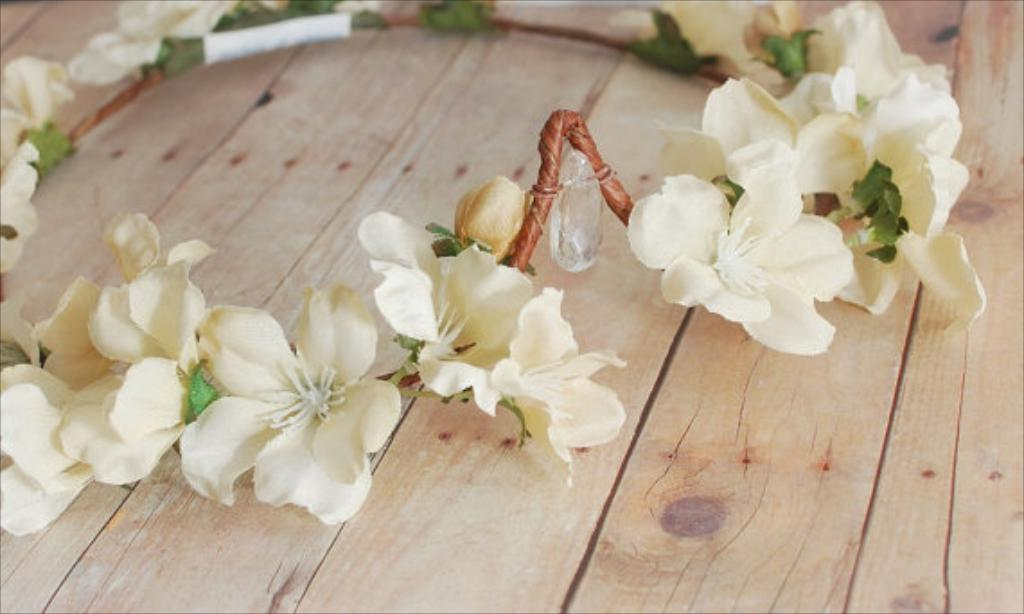What is on the floor in the image? There are flowers on the floor in the image. Are there any other objects or items on the floor besides the flowers? The image only shows flowers on the floor. What type of magic is being performed with the needle and tray in the image? There is no needle or tray present in the image, and therefore no magic can be observed. 